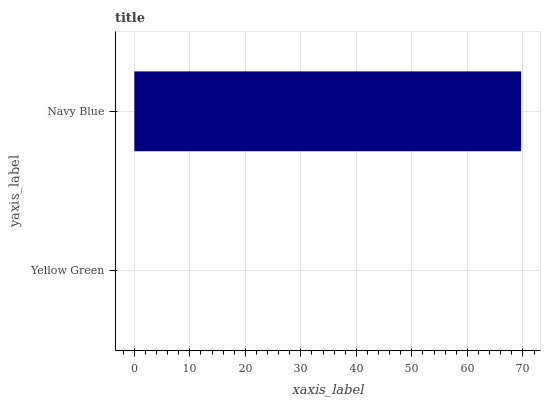Is Yellow Green the minimum?
Answer yes or no. Yes. Is Navy Blue the maximum?
Answer yes or no. Yes. Is Navy Blue the minimum?
Answer yes or no. No. Is Navy Blue greater than Yellow Green?
Answer yes or no. Yes. Is Yellow Green less than Navy Blue?
Answer yes or no. Yes. Is Yellow Green greater than Navy Blue?
Answer yes or no. No. Is Navy Blue less than Yellow Green?
Answer yes or no. No. Is Navy Blue the high median?
Answer yes or no. Yes. Is Yellow Green the low median?
Answer yes or no. Yes. Is Yellow Green the high median?
Answer yes or no. No. Is Navy Blue the low median?
Answer yes or no. No. 